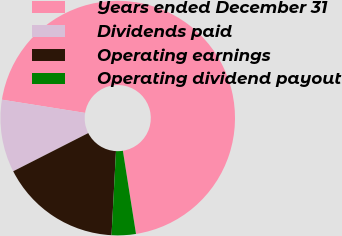Convert chart. <chart><loc_0><loc_0><loc_500><loc_500><pie_chart><fcel>Years ended December 31<fcel>Dividends paid<fcel>Operating earnings<fcel>Operating dividend payout<nl><fcel>70.0%<fcel>10.0%<fcel>16.67%<fcel>3.33%<nl></chart> 